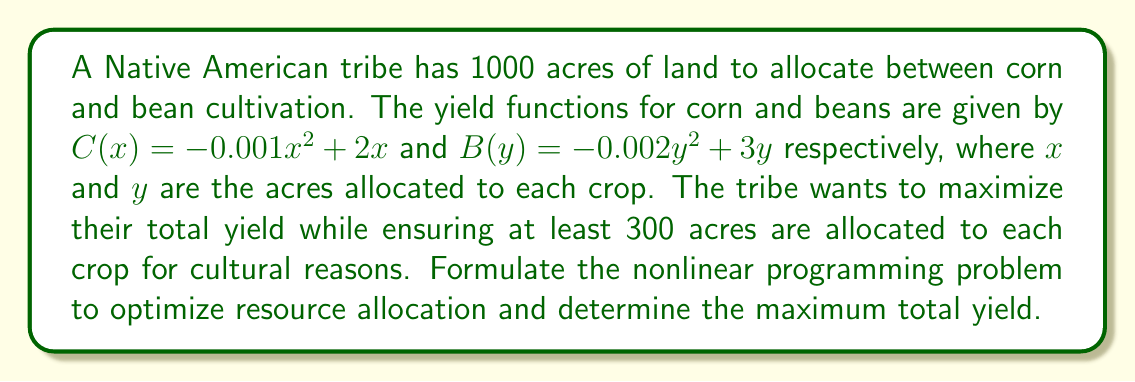Can you answer this question? 1. Define the objective function:
   Maximize $Z = C(x) + B(y) = (-0.001x^2 + 2x) + (-0.002y^2 + 3y)$

2. Set up constraints:
   $x + y \leq 1000$ (total land constraint)
   $x \geq 300$ and $y \geq 300$ (cultural constraints)

3. Formulate the nonlinear programming problem:
   Maximize $Z = -0.001x^2 + 2x - 0.002y^2 + 3y$
   Subject to:
   $x + y \leq 1000$
   $x \geq 300$
   $y \geq 300$

4. To solve, use the method of Lagrange multipliers:
   $L = -0.001x^2 + 2x - 0.002y^2 + 3y + \lambda(1000 - x - y)$

5. Take partial derivatives and set them to zero:
   $\frac{\partial L}{\partial x} = -0.002x + 2 - \lambda = 0$
   $\frac{\partial L}{\partial y} = -0.004y + 3 - \lambda = 0$
   $\frac{\partial L}{\partial \lambda} = 1000 - x - y = 0$

6. Solve the system of equations:
   $x = 1000 - y$
   $-0.002(1000 - y) + 2 = -0.004y + 3$
   $-2 + 0.002y + 2 = -0.004y + 3$
   $0.006y = 3$
   $y = 500$
   $x = 500$

7. Check if the solution satisfies the cultural constraints:
   $x = 500 > 300$ and $y = 500 > 300$, so the constraints are satisfied.

8. Calculate the maximum total yield:
   $Z = (-0.001(500)^2 + 2(500)) + (-0.002(500)^2 + 3(500))$
   $Z = (750) + (1250) = 2000$
Answer: 2000 units 